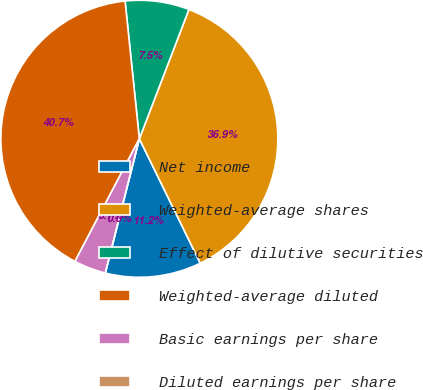<chart> <loc_0><loc_0><loc_500><loc_500><pie_chart><fcel>Net income<fcel>Weighted-average shares<fcel>Effect of dilutive securities<fcel>Weighted-average diluted<fcel>Basic earnings per share<fcel>Diluted earnings per share<nl><fcel>11.2%<fcel>36.93%<fcel>7.47%<fcel>40.66%<fcel>3.74%<fcel>0.0%<nl></chart> 